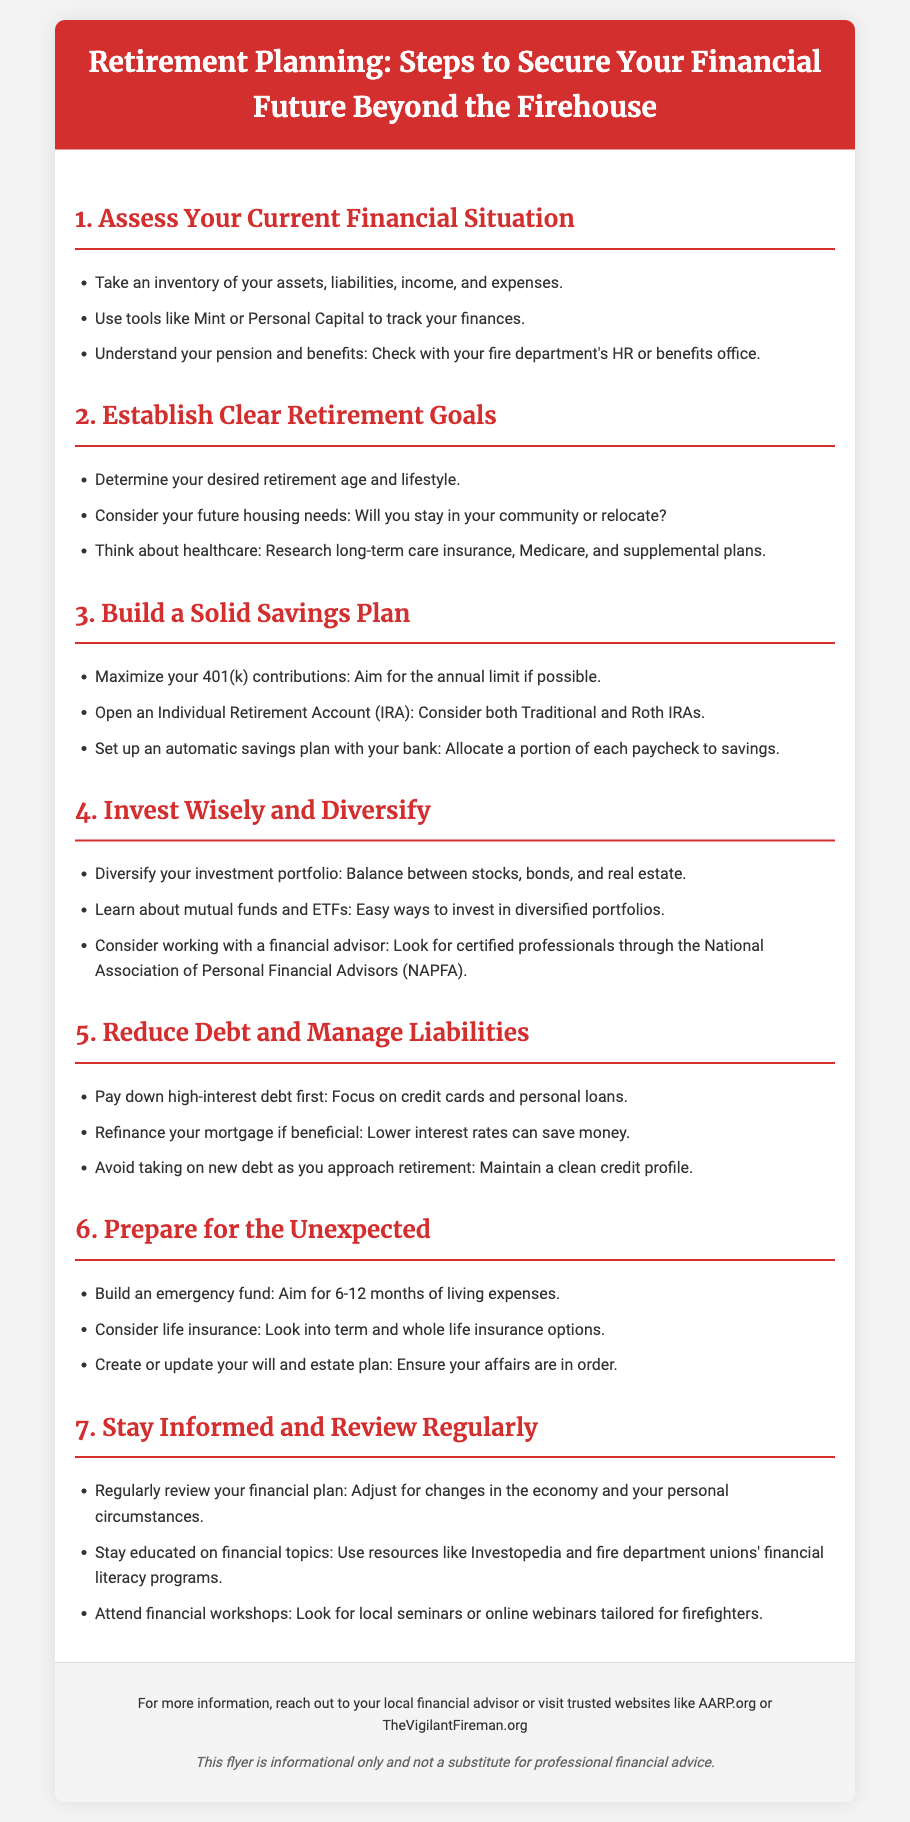what is the title of the flyer? The title of the flyer is stated prominently at the top of the document.
Answer: Retirement Planning: Steps to Secure Your Financial Future Beyond the Firehouse how many steps are outlined for retirement planning? The number of steps can be identified within the content sections of the flyer.
Answer: 7 what should you maximize according to step 3? Step 3 emphasizes a specific investment account that should have its contributions maximized.
Answer: 401(k) contributions what is recommended to aim for when building an emergency fund in step 6? Step 6 specifies a recommended duration for an emergency fund based on living expenses.
Answer: 6-12 months which investment types are suggested to diversify your portfolio in step 4? Step 4 mentions specific types of investments to consider for diversification.
Answer: stocks, bonds, and real estate who can provide more information apart from financial advisors? The footer of the document provides resources for additional information beyond financial advisors.
Answer: AARP.org or TheVigilantFireman.org what is one financial tool mentioned in step 1? Step 1 lists a suggestion for a financial management tool that can aid in tracking finances.
Answer: Mint or Personal Capital 